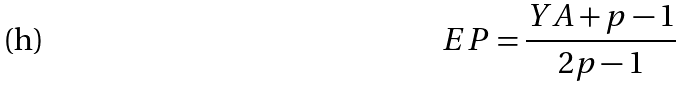Convert formula to latex. <formula><loc_0><loc_0><loc_500><loc_500>E P = \frac { Y A + p - 1 } { 2 p - 1 }</formula> 